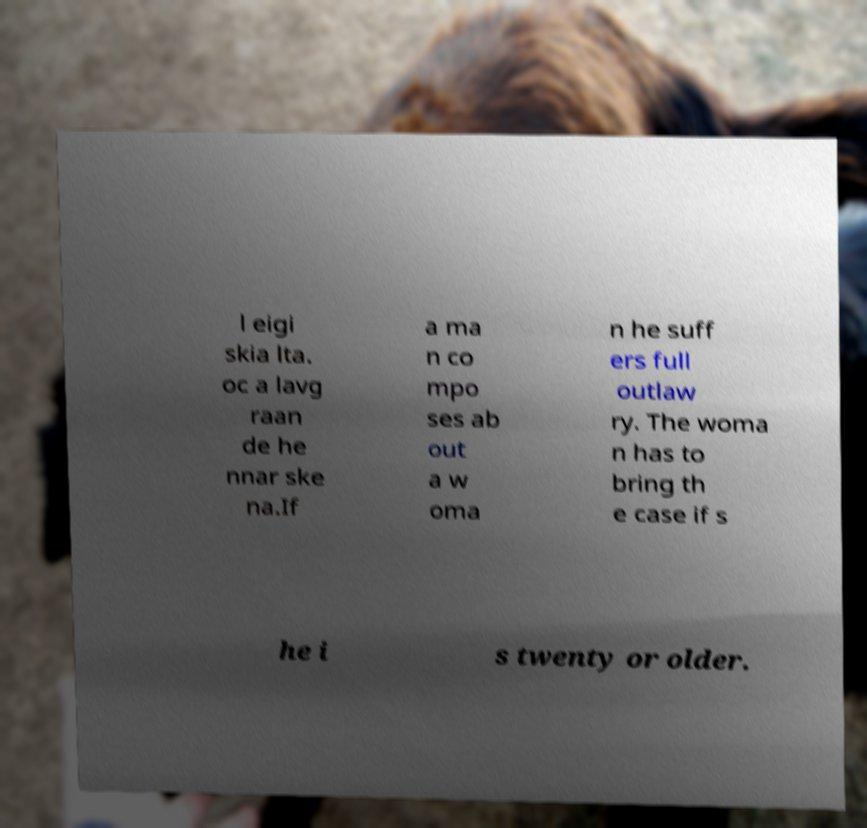I need the written content from this picture converted into text. Can you do that? l eigi skia lta. oc a lavg raan de he nnar ske na.If a ma n co mpo ses ab out a w oma n he suff ers full outlaw ry. The woma n has to bring th e case if s he i s twenty or older. 